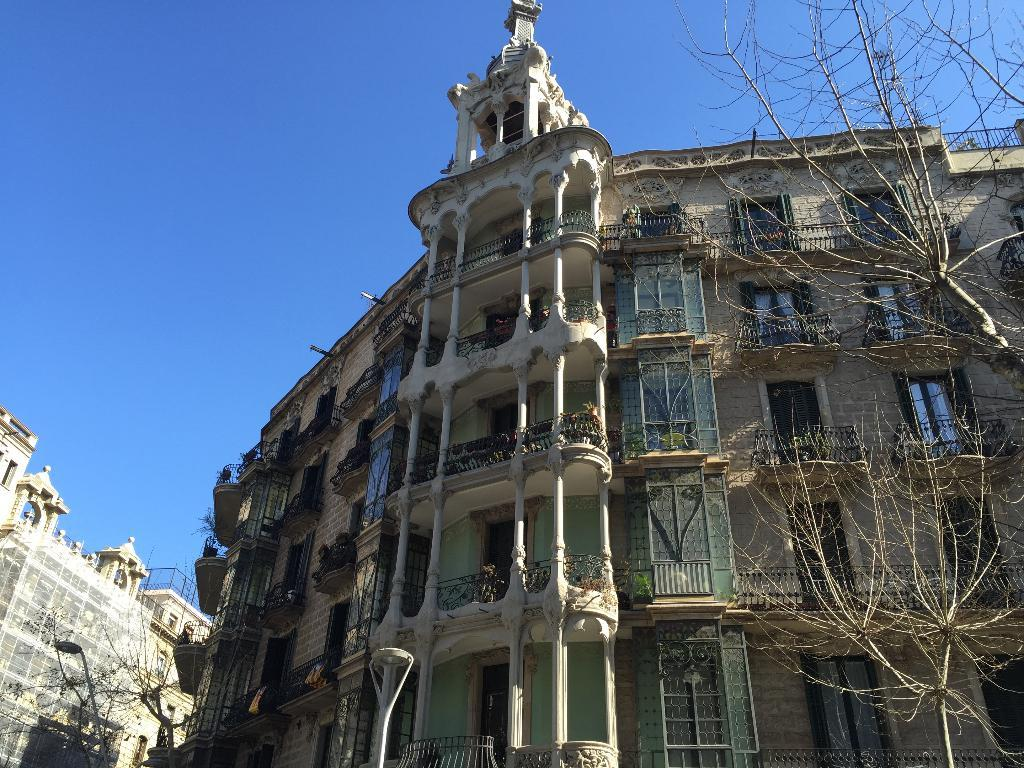What type of vegetation can be seen in the image? There are trees in the image. What type of man-made structures are present in the image? There are buildings in the image. What type of lighting fixture is visible in the image? There is a street light in the image. What part of the natural environment is visible in the image? The sky is visible in the background of the image. Can you tell me how many cherries are hanging from the trees in the image? There is no mention of cherries in the image; it features trees, buildings, a street light, and the sky. What type of reward is being given to the person in the image? There is no person or reward present in the image. 